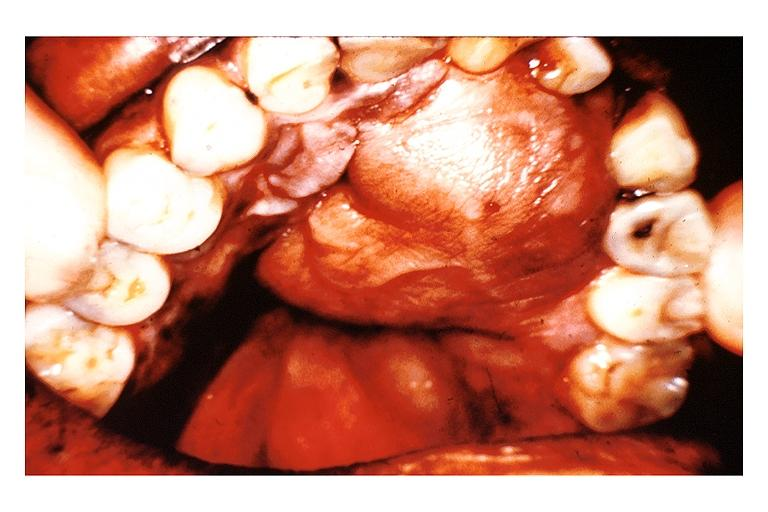s opened uterus and cervix with large cervical myoma protruding into vagina slide present?
Answer the question using a single word or phrase. No 